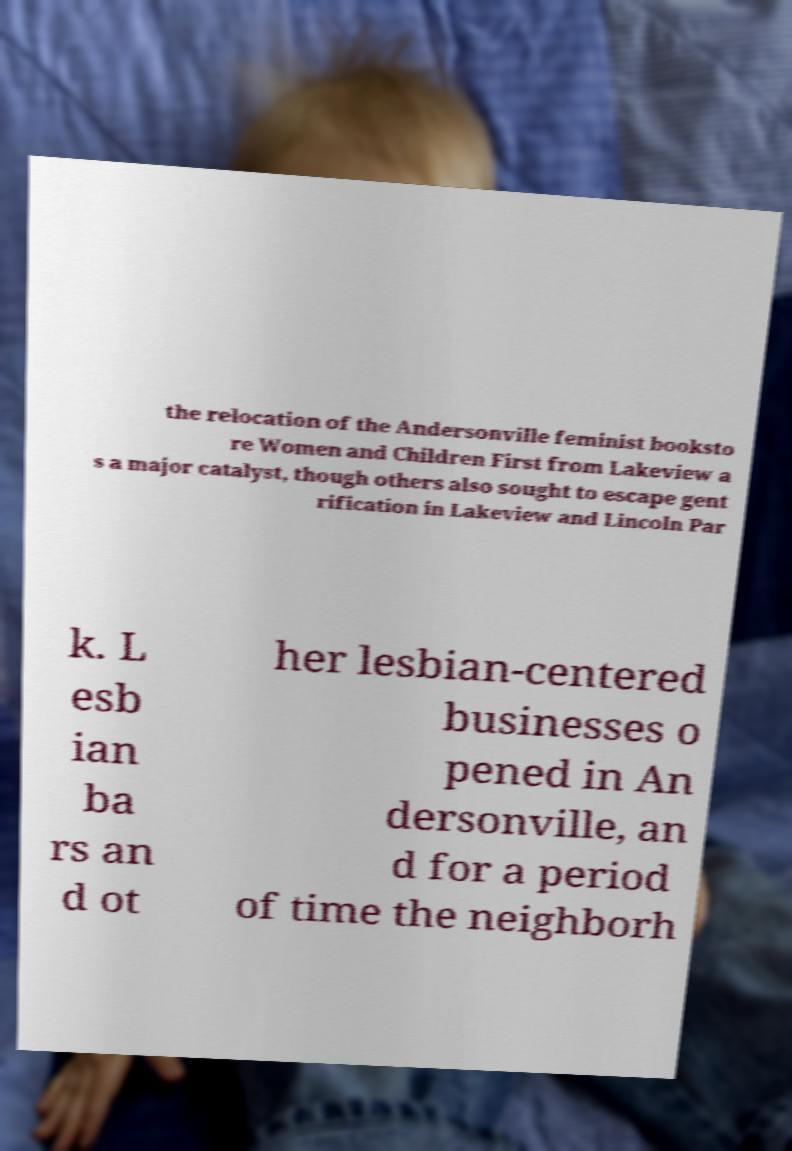Could you assist in decoding the text presented in this image and type it out clearly? the relocation of the Andersonville feminist booksto re Women and Children First from Lakeview a s a major catalyst, though others also sought to escape gent rification in Lakeview and Lincoln Par k. L esb ian ba rs an d ot her lesbian-centered businesses o pened in An dersonville, an d for a period of time the neighborh 